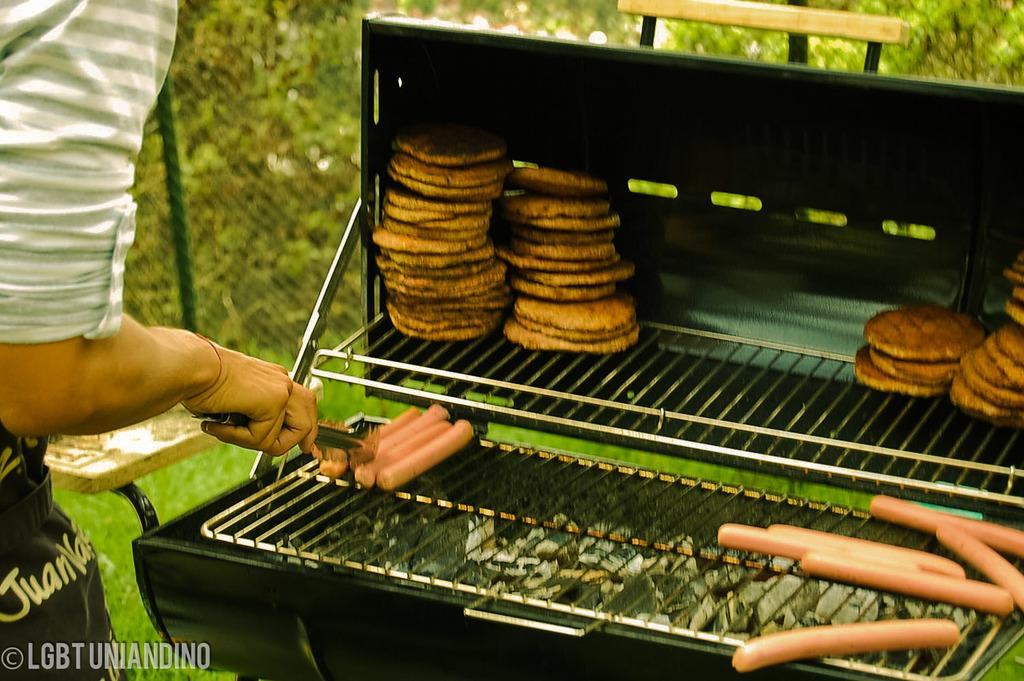Provide a one-sentence caption for the provided image. A person arranging hotdogs on a charcoal grill. 